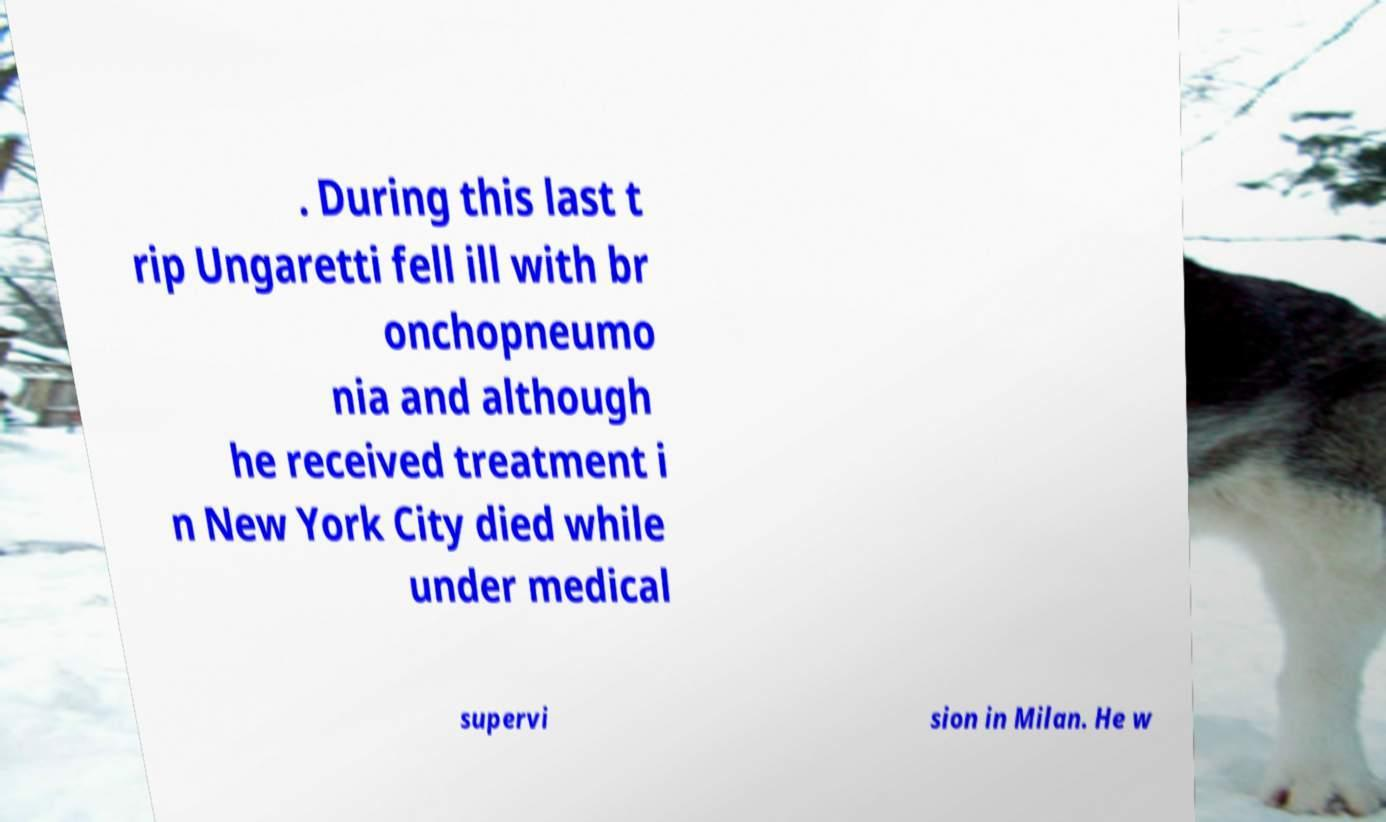Can you read and provide the text displayed in the image?This photo seems to have some interesting text. Can you extract and type it out for me? . During this last t rip Ungaretti fell ill with br onchopneumo nia and although he received treatment i n New York City died while under medical supervi sion in Milan. He w 